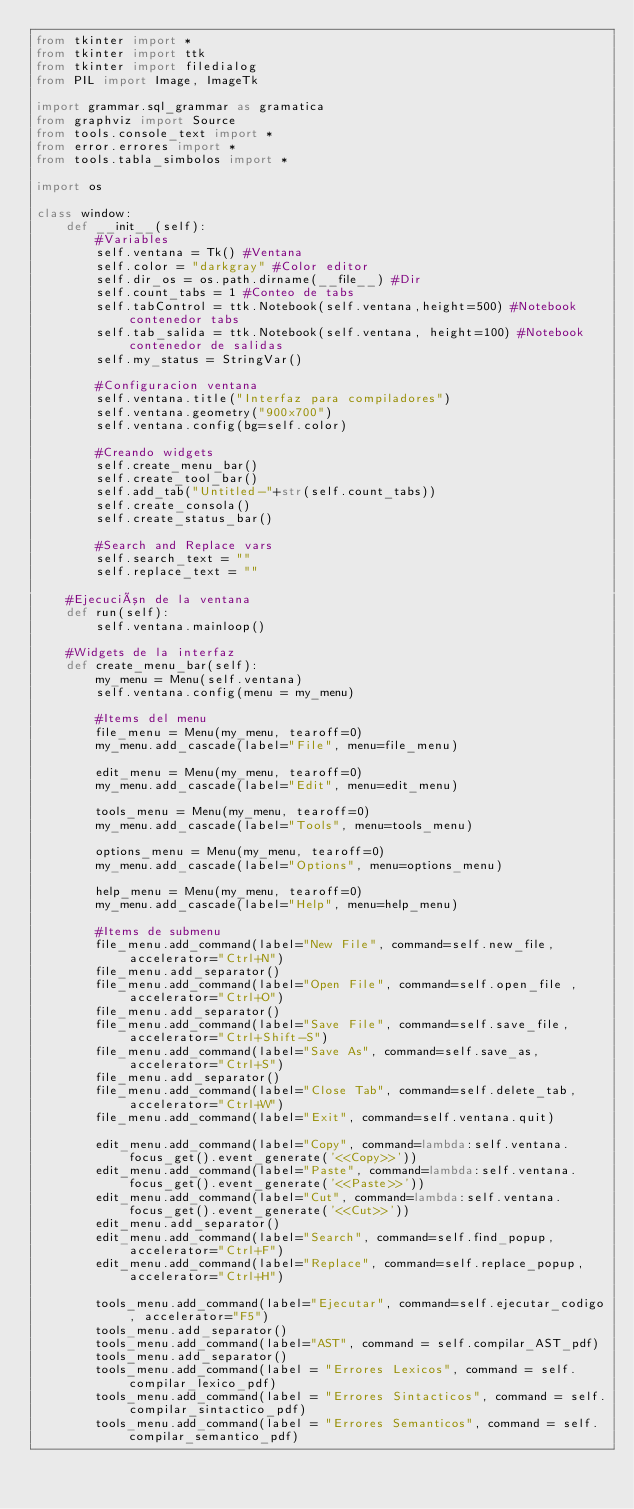Convert code to text. <code><loc_0><loc_0><loc_500><loc_500><_Python_>from tkinter import *
from tkinter import ttk
from tkinter import filedialog
from PIL import Image, ImageTk

import grammar.sql_grammar as gramatica
from graphviz import Source
from tools.console_text import *
from error.errores import *
from tools.tabla_simbolos import *

import os

class window:
    def __init__(self):
        #Variables 
        self.ventana = Tk() #Ventana
        self.color = "darkgray" #Color editor
        self.dir_os = os.path.dirname(__file__) #Dir 
        self.count_tabs = 1 #Conteo de tabs
        self.tabControl = ttk.Notebook(self.ventana,height=500) #Notebook contenedor tabs
        self.tab_salida = ttk.Notebook(self.ventana, height=100) #Notebook contenedor de salidas     
        self.my_status = StringVar()

        #Configuracion ventana
        self.ventana.title("Interfaz para compiladores")
        self.ventana.geometry("900x700")
        self.ventana.config(bg=self.color)

        #Creando widgets
        self.create_menu_bar()
        self.create_tool_bar()
        self.add_tab("Untitled-"+str(self.count_tabs))
        self.create_consola()
        self.create_status_bar()

        #Search and Replace vars
        self.search_text = ""
        self.replace_text = ""
       
    #Ejecución de la ventana
    def run(self):
        self.ventana.mainloop()
    
    #Widgets de la interfaz
    def create_menu_bar(self):
        my_menu = Menu(self.ventana)
        self.ventana.config(menu = my_menu)

        #Items del menu
        file_menu = Menu(my_menu, tearoff=0)
        my_menu.add_cascade(label="File", menu=file_menu)

        edit_menu = Menu(my_menu, tearoff=0)
        my_menu.add_cascade(label="Edit", menu=edit_menu)

        tools_menu = Menu(my_menu, tearoff=0)
        my_menu.add_cascade(label="Tools", menu=tools_menu)

        options_menu = Menu(my_menu, tearoff=0)
        my_menu.add_cascade(label="Options", menu=options_menu)

        help_menu = Menu(my_menu, tearoff=0)
        my_menu.add_cascade(label="Help", menu=help_menu)

        #Items de submenu
        file_menu.add_command(label="New File", command=self.new_file, accelerator="Ctrl+N")
        file_menu.add_separator()
        file_menu.add_command(label="Open File", command=self.open_file , accelerator="Ctrl+O")
        file_menu.add_separator()
        file_menu.add_command(label="Save File", command=self.save_file, accelerator="Ctrl+Shift-S")
        file_menu.add_command(label="Save As", command=self.save_as, accelerator="Ctrl+S")
        file_menu.add_separator()
        file_menu.add_command(label="Close Tab", command=self.delete_tab, accelerator="Ctrl+W")
        file_menu.add_command(label="Exit", command=self.ventana.quit)

        edit_menu.add_command(label="Copy", command=lambda:self.ventana.focus_get().event_generate('<<Copy>>'))
        edit_menu.add_command(label="Paste", command=lambda:self.ventana.focus_get().event_generate('<<Paste>>'))
        edit_menu.add_command(label="Cut", command=lambda:self.ventana.focus_get().event_generate('<<Cut>>'))
        edit_menu.add_separator()
        edit_menu.add_command(label="Search", command=self.find_popup, accelerator="Ctrl+F")
        edit_menu.add_command(label="Replace", command=self.replace_popup, accelerator="Ctrl+H")

        tools_menu.add_command(label="Ejecutar", command=self.ejecutar_codigo, accelerator="F5")
        tools_menu.add_separator()
        tools_menu.add_command(label="AST", command = self.compilar_AST_pdf)
        tools_menu.add_separator()
        tools_menu.add_command(label = "Errores Lexicos", command = self.compilar_lexico_pdf)
        tools_menu.add_command(label = "Errores Sintacticos", command = self.compilar_sintactico_pdf)
        tools_menu.add_command(label = "Errores Semanticos", command = self.compilar_semantico_pdf)</code> 